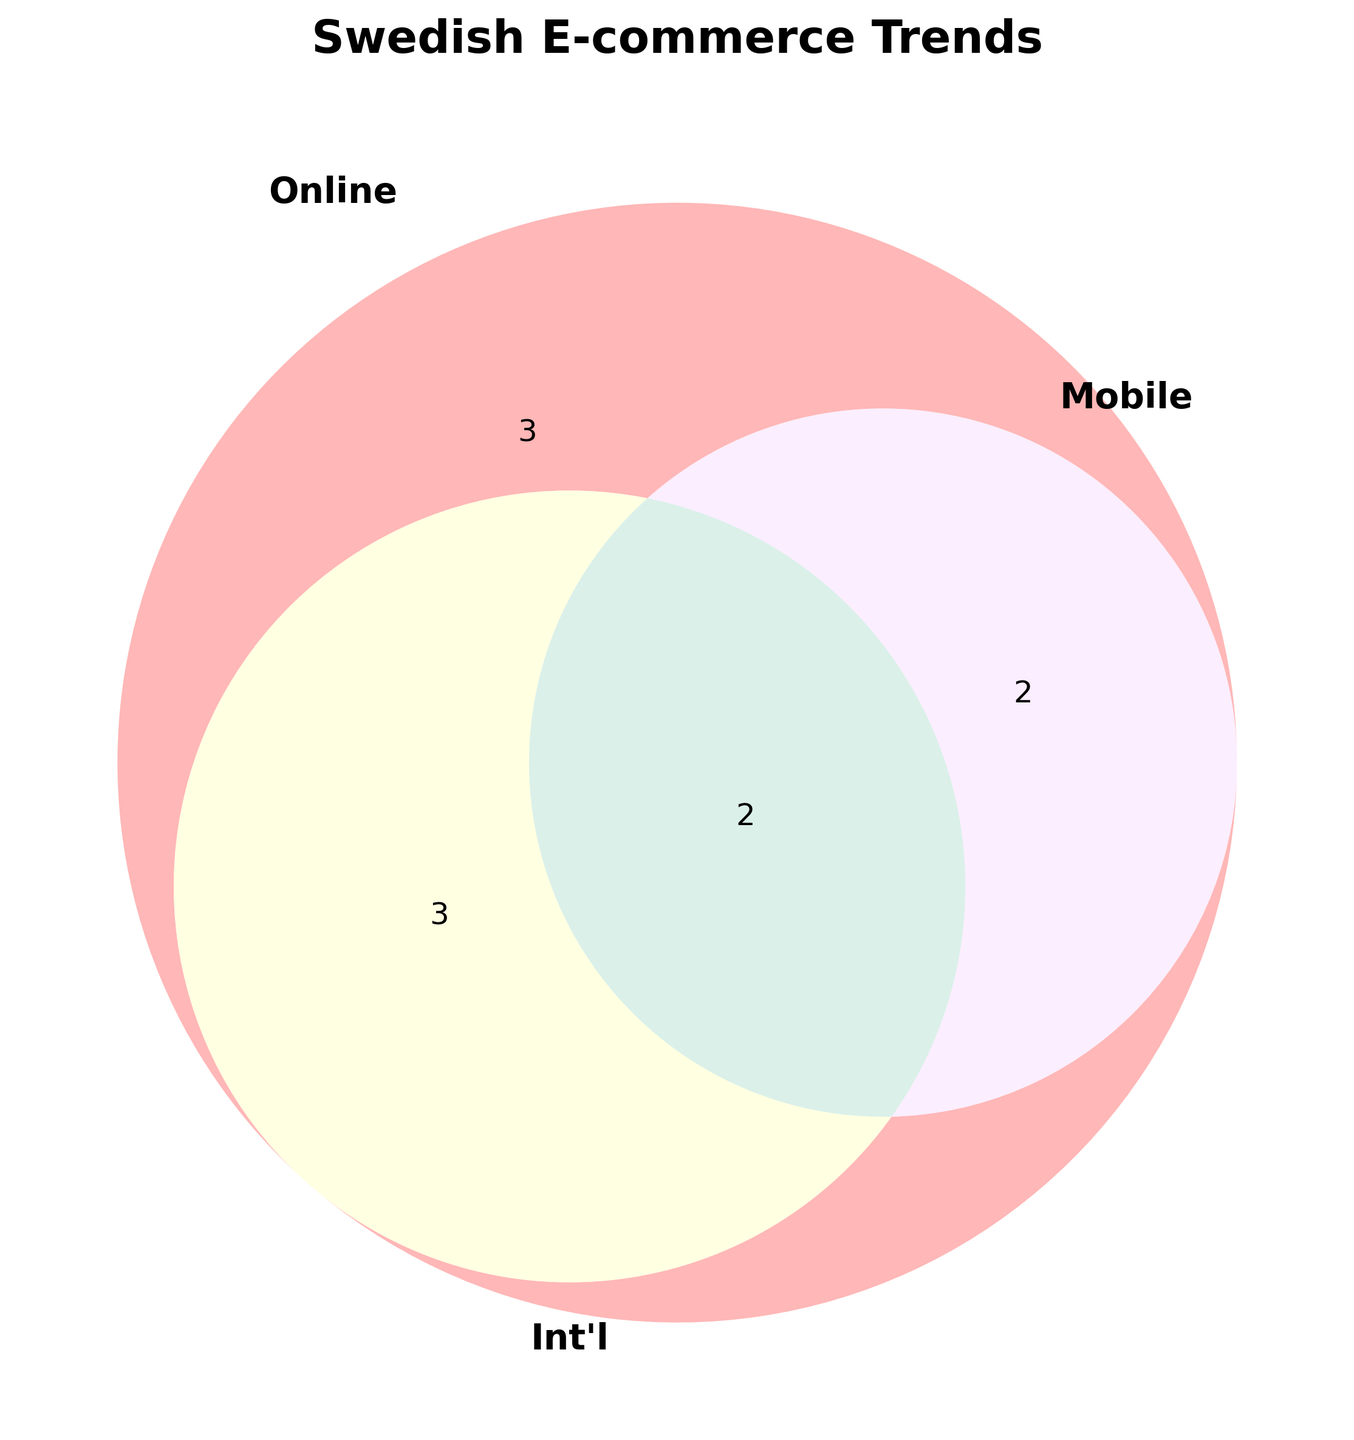What are the three categories where all users overlap? From the Venn diagram, identify the section where all three circles (Online, Mobile, Int'l) overlap. Those sections are the intersections representing all three categories.
Answer: Electronics, Travel Accessories How many categories belong only to Online Shoppers? Identify the area of the Online circle that does not intersect with Mobile or Int'l circles. Count those categories.
Answer: 1 Which category is shared between Online Shoppers and International Buyers but not Mobile Users? Look for the intersection between Online and Int'l circles that does not overlap with the Mobile circle.
Answer: Home Decor How many categories are unique to Mobile Users? Identify the area of the Mobile circle that does not intersect with Online or Int'l circles. Count those categories.
Answer: 0 Do International Buyers overlap more with Online Shoppers or Mobile Users? Compare the intersection areas of the Int'l circle with the Online and Mobile circles. Count the number of shared categories in each case.
Answer: Online Shoppers Which category is shared between Online Shoppers and Mobile Users only? Look for the intersection between the Online and Mobile circles that does not overlap with the Int'l circle.
Answer: Fashion How many categories overlap between Online Shoppers and Int'l Buyers but not Mobile Users? Identify the intersection between Online and Int'l circles that does not overlap with the Mobile circle. Count those categories.
Answer: 3 Which category is only associated with Online Shoppers? Identify the category inside the Online circle that does not intersect with Mobile or Int'l circles.
Answer: Groceries Are there any categories exclusive to Mobile Users? Check if there is any section solely within the Mobile circle that does not intersect with Online or Int'l circles.
Answer: No Which category is included in both Mobile Users and Int'l Buyers but not Online Shoppers? Identify the intersection area between Mobile and Int'l circles without intersecting the Online circle.
Answer: There is none 